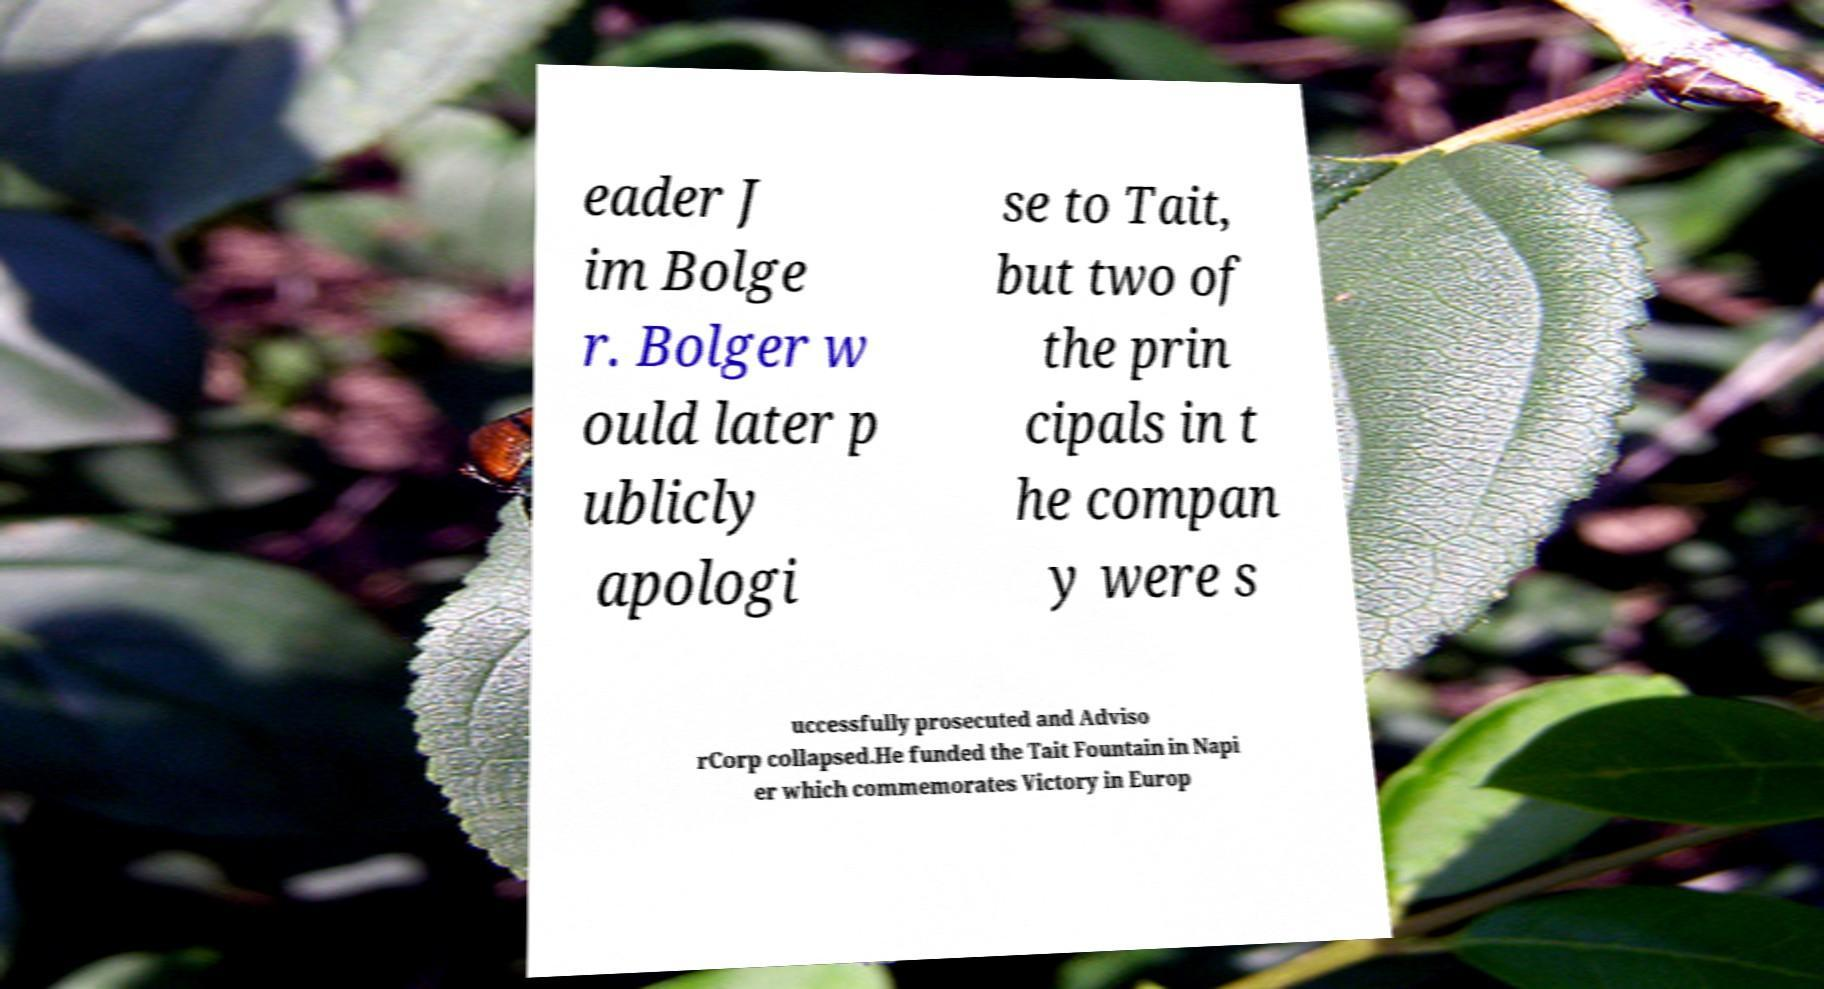What messages or text are displayed in this image? I need them in a readable, typed format. eader J im Bolge r. Bolger w ould later p ublicly apologi se to Tait, but two of the prin cipals in t he compan y were s uccessfully prosecuted and Adviso rCorp collapsed.He funded the Tait Fountain in Napi er which commemorates Victory in Europ 